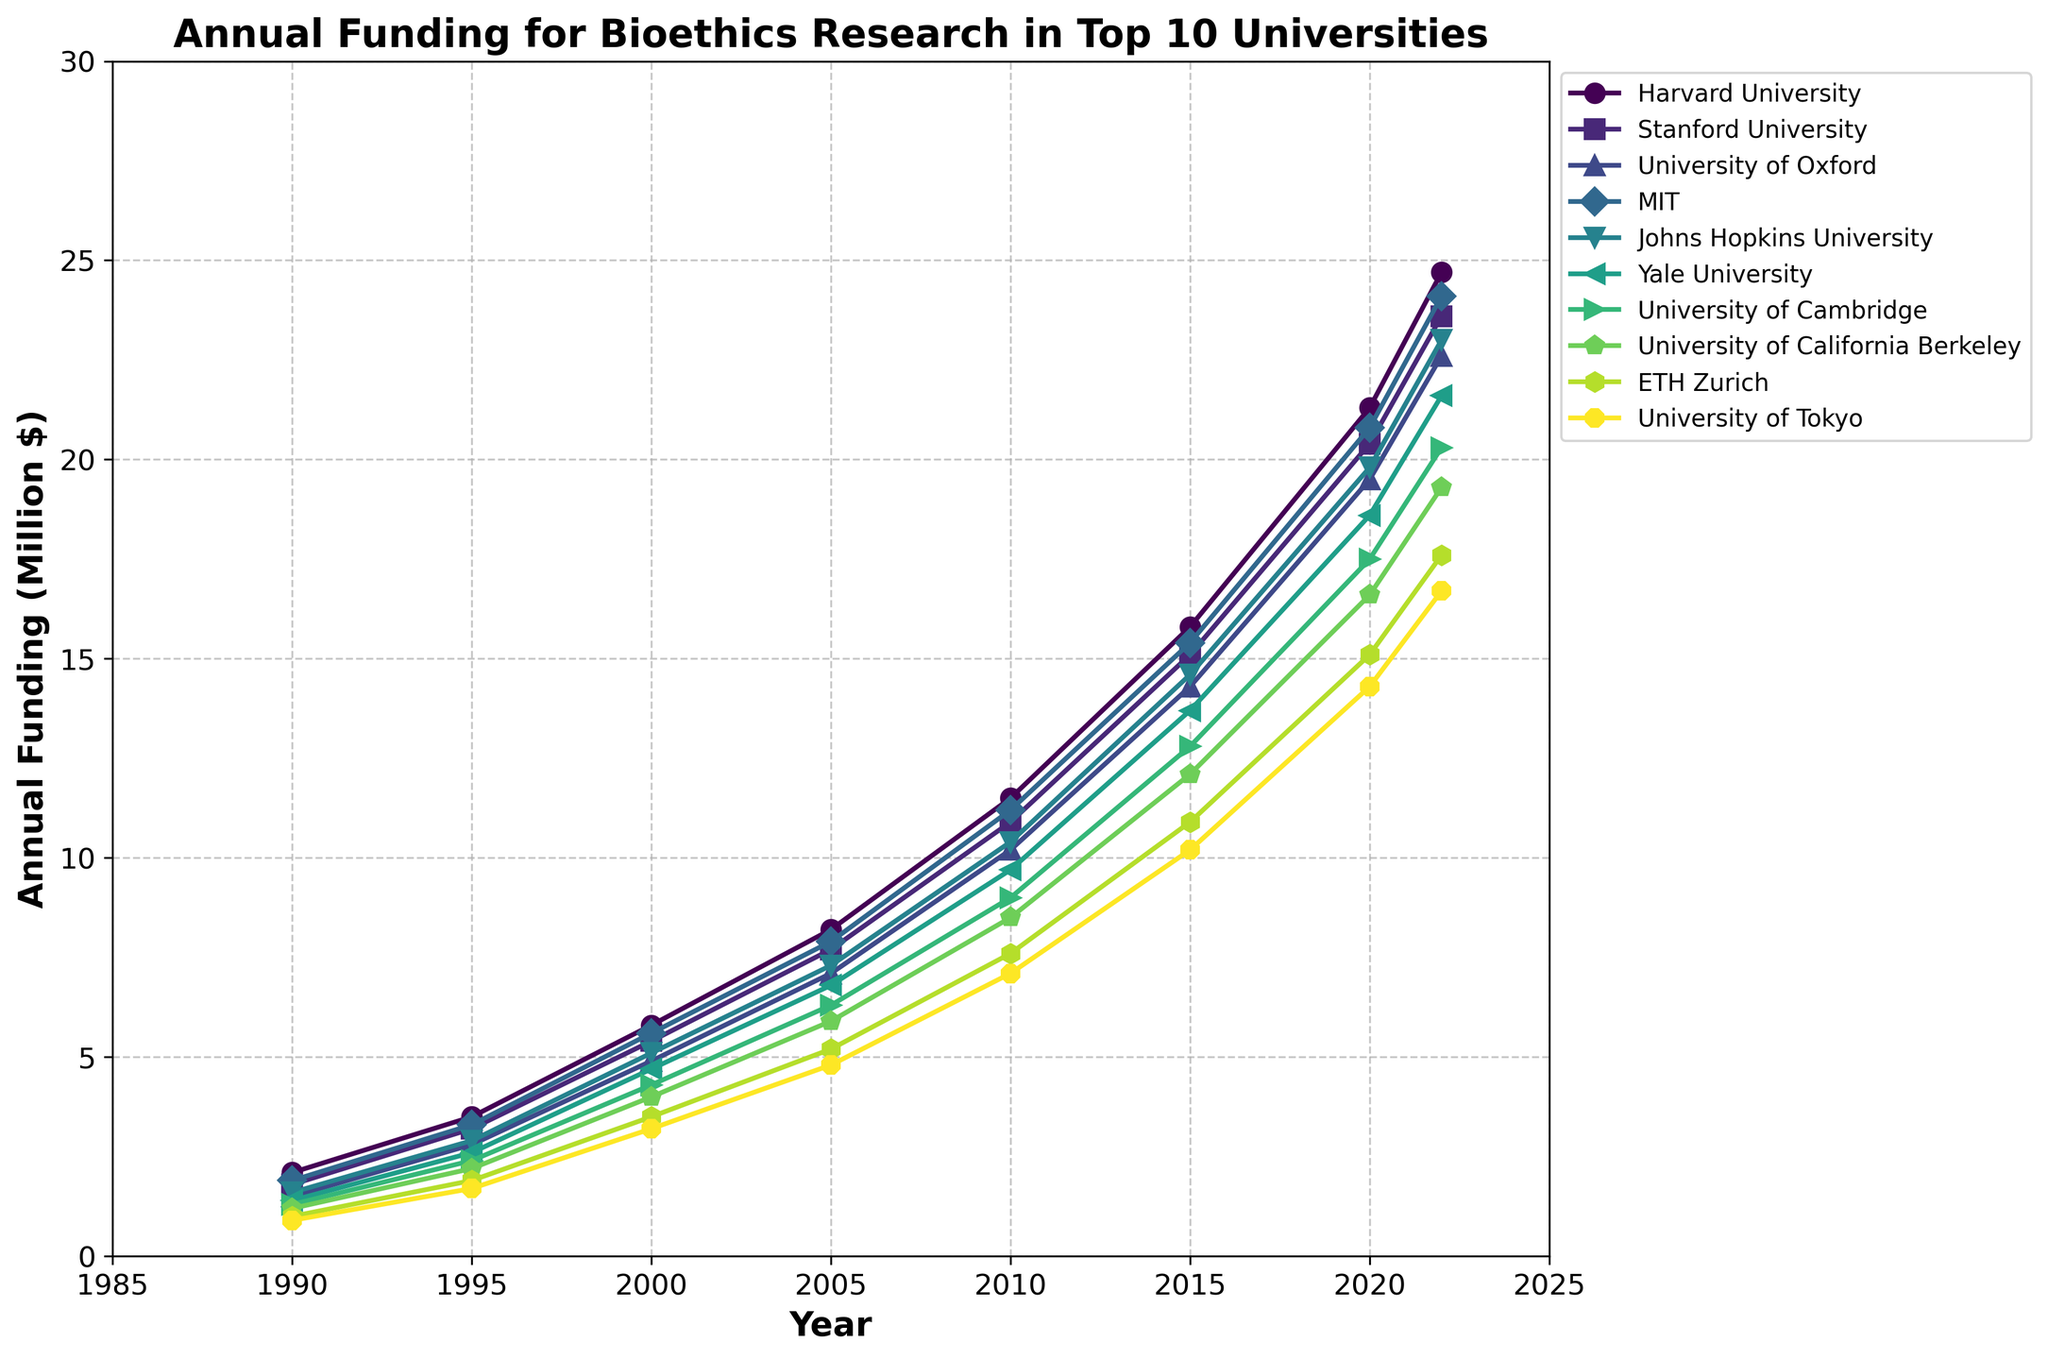Which university had the highest funding for bioethics research in 1990? Look at the markers for the year 1990 on the x-axis and identify the highest marker. Harvard University has the highest marker.
Answer: Harvard University By how much did the funding for Yale University increase from 2000 to 2020? Find Yale University's funding values in 2000 and 2020 from the y-axis. Subtract the 2000 value from the 2020 value: 18.6 - 4.7 = 13.9 million $.
Answer: 13.9 million $ Which two universities had the closest funding values in 2022? Look at the ending markers for 2022 and compare their positions. Stanford University and University of Cambridge have the closest values, visually almost overlapping.
Answer: Stanford University and University of Cambridge What is the average funding for MIT between 2000 and 2020? Sum the funding values for MIT in the given years 2000, 2005, 2010, 2015, and 2020, then divide by 5: (5.6 + 7.9 + 11.2 + 15.4 + 20.8) / 5 = 12.18 million $.
Answer: 12.18 million $ Which universities have shown a consistent increase in funding every year from 1990 to 2022? Check the funding lines for each university from left to right. All lines consistently sloping upward without any decreases identify Harvard University, Stanford University, MIT, and the University of Tokyo.
Answer: Harvard University, Stanford University, MIT, University of Tokyo What is the total funding for all universities in 1995? Add up the funding values for all universities in the year 1995: 3.5 + 3.2 + 2.8 + 3.3 + 2.9 + 2.6 + 2.4 + 2.2 + 1.9 + 1.7 = 28.5 million $.
Answer: 28.5 million $ Between which two consecutive years did Harvard University see the biggest jump in funding? Analyze the funding increments between consecutive years for Harvard University and identify the largest change: From 2010 (11.5) to 2015 (15.8), the change is 4.3 million $, which is the largest.
Answer: 2010 to 2015 Which university has the steepest slope in its funding trend from 1990 to 2022? Look for the line with the steepest slope from left to right, indicating the largest overall increase. Harvard University has the steepest slope.
Answer: Harvard University Which university had less than 5 million $ in funding only up to the year 2000? Identify the lines that cross the 5 million $ mark only after or in the year 2000. ETH Zurich and the University of Tokyo fulfill this criterion.
Answer: ETH Zurich and University of Tokyo 